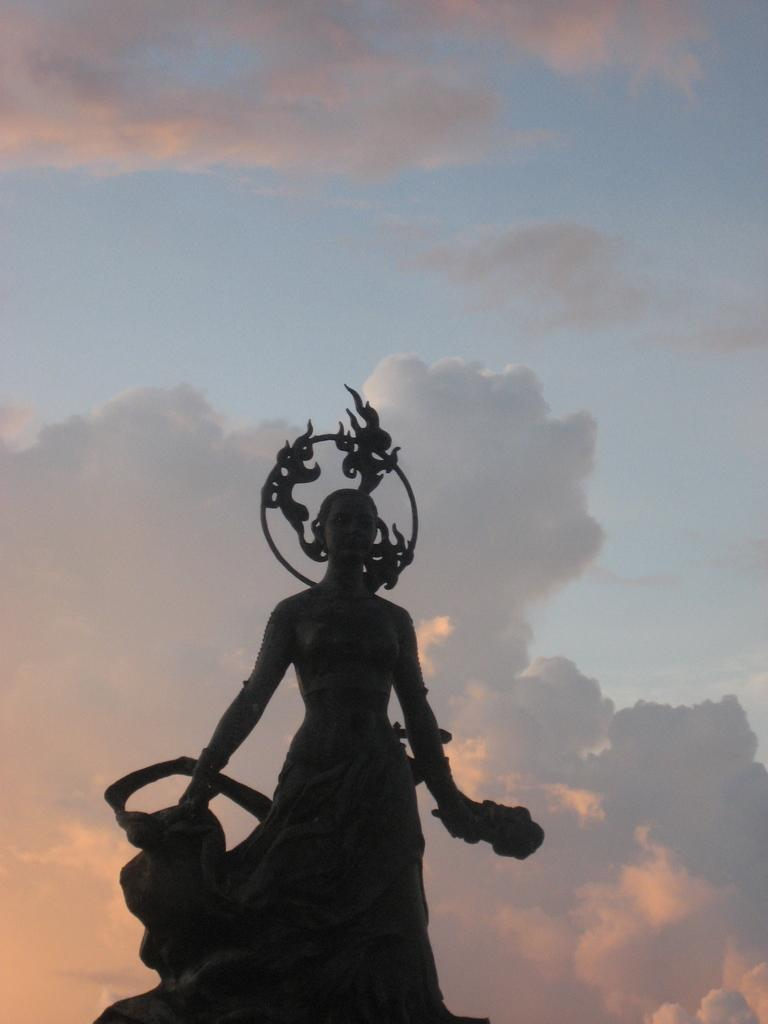What is the main subject in the image? There is a statue in the image. What can be seen in the sky in the image? There are clouds visible in the sky in the image. What type of match is being played in the image? There is no match being played in the image; it features a statue and clouds in the sky. What fact can be determined about the sun's position in the image? The sun's position cannot be determined from the image, as it only shows a statue and clouds in the sky. 